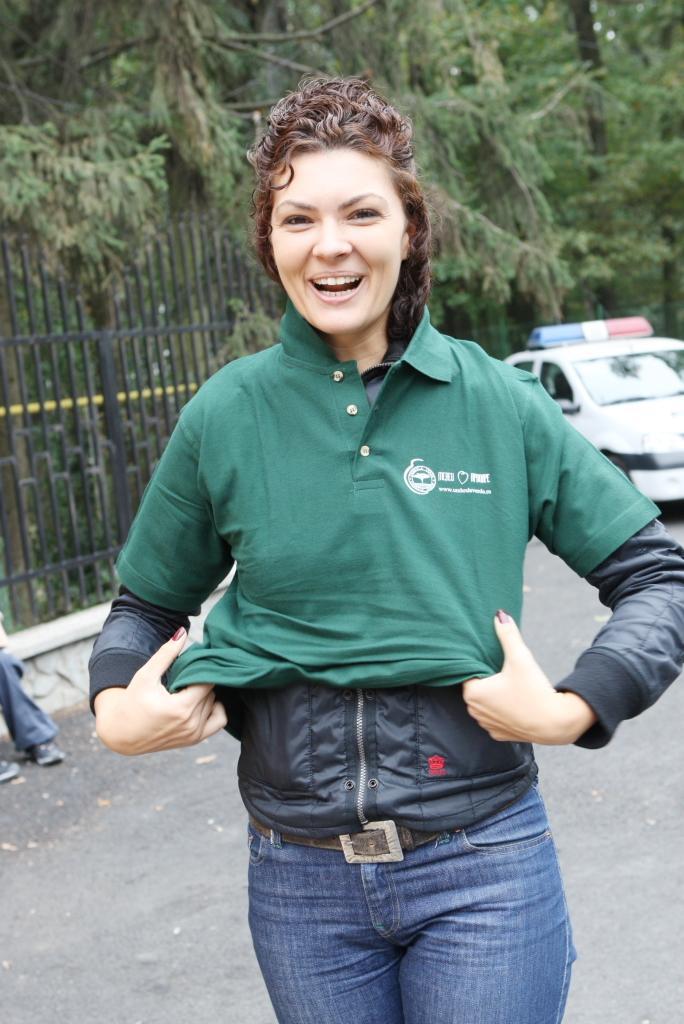How would you summarize this image in a sentence or two? In this image there is a woman standing towards the bottom of the image, there is road towards the bottom of the image, there is a person's leg towards the left of the image, there is a metal fence towards the left of the image, there is a car towards the right of the image, at the background of the image there are trees. 